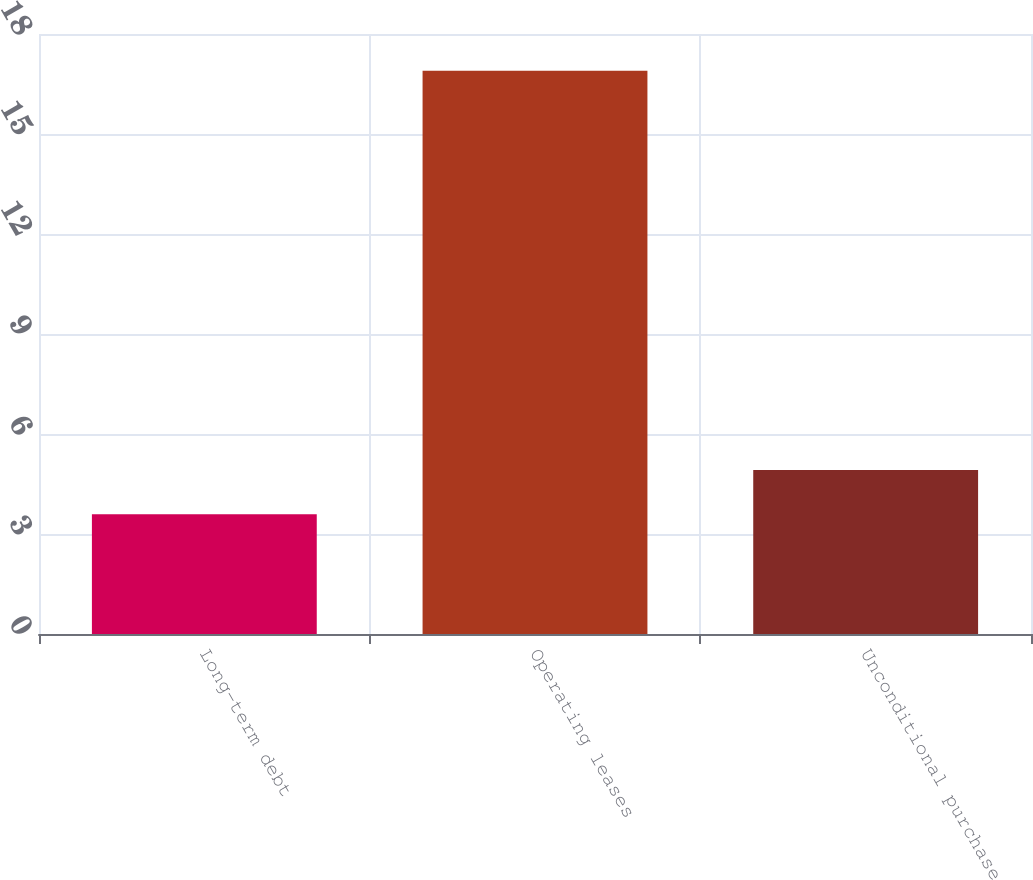<chart> <loc_0><loc_0><loc_500><loc_500><bar_chart><fcel>Long-term debt<fcel>Operating leases<fcel>Unconditional purchase<nl><fcel>3.59<fcel>16.9<fcel>4.92<nl></chart> 